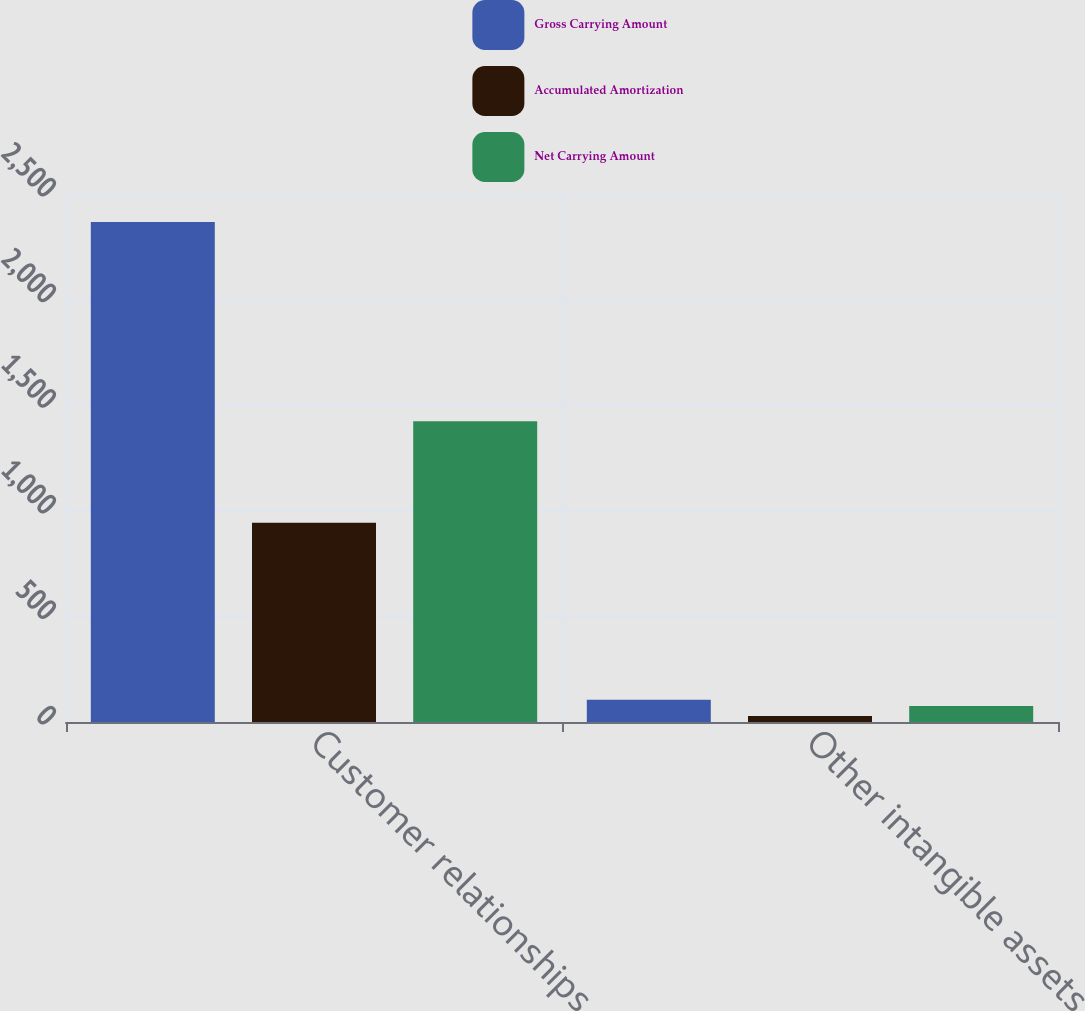Convert chart. <chart><loc_0><loc_0><loc_500><loc_500><stacked_bar_chart><ecel><fcel>Customer relationships<fcel>Other intangible assets<nl><fcel>Gross Carrying Amount<fcel>2368<fcel>105<nl><fcel>Accumulated Amortization<fcel>944<fcel>29<nl><fcel>Net Carrying Amount<fcel>1424<fcel>76<nl></chart> 